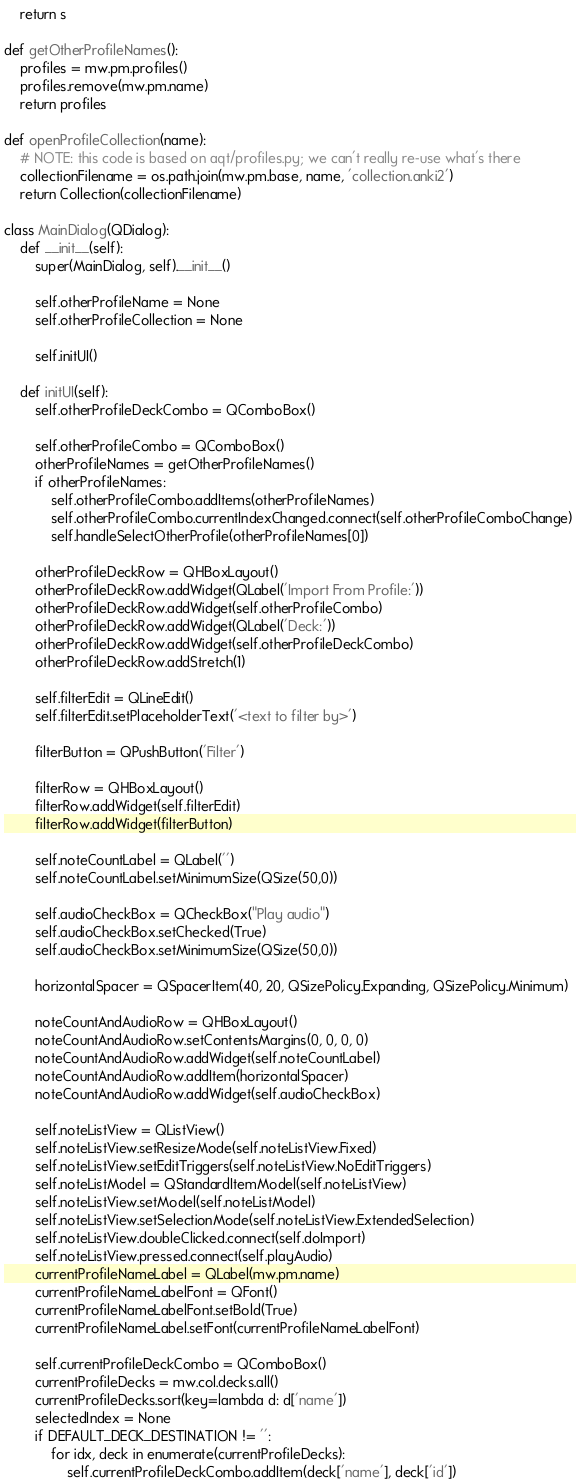Convert code to text. <code><loc_0><loc_0><loc_500><loc_500><_Python_>    return s

def getOtherProfileNames():
    profiles = mw.pm.profiles()
    profiles.remove(mw.pm.name)
    return profiles

def openProfileCollection(name):
    # NOTE: this code is based on aqt/profiles.py; we can't really re-use what's there
    collectionFilename = os.path.join(mw.pm.base, name, 'collection.anki2')
    return Collection(collectionFilename)

class MainDialog(QDialog):
    def __init__(self):
        super(MainDialog, self).__init__()

        self.otherProfileName = None
        self.otherProfileCollection = None

        self.initUI()

    def initUI(self):
        self.otherProfileDeckCombo = QComboBox()

        self.otherProfileCombo = QComboBox()
        otherProfileNames = getOtherProfileNames()
        if otherProfileNames:
            self.otherProfileCombo.addItems(otherProfileNames)
            self.otherProfileCombo.currentIndexChanged.connect(self.otherProfileComboChange)
            self.handleSelectOtherProfile(otherProfileNames[0])

        otherProfileDeckRow = QHBoxLayout()
        otherProfileDeckRow.addWidget(QLabel('Import From Profile:'))
        otherProfileDeckRow.addWidget(self.otherProfileCombo)
        otherProfileDeckRow.addWidget(QLabel('Deck:'))
        otherProfileDeckRow.addWidget(self.otherProfileDeckCombo)
        otherProfileDeckRow.addStretch(1)

        self.filterEdit = QLineEdit()
        self.filterEdit.setPlaceholderText('<text to filter by>')

        filterButton = QPushButton('Filter')

        filterRow = QHBoxLayout()
        filterRow.addWidget(self.filterEdit)
        filterRow.addWidget(filterButton)

        self.noteCountLabel = QLabel('')
        self.noteCountLabel.setMinimumSize(QSize(50,0))

        self.audioCheckBox = QCheckBox("Play audio")
        self.audioCheckBox.setChecked(True)
        self.audioCheckBox.setMinimumSize(QSize(50,0))

        horizontalSpacer = QSpacerItem(40, 20, QSizePolicy.Expanding, QSizePolicy.Minimum)

        noteCountAndAudioRow = QHBoxLayout()
        noteCountAndAudioRow.setContentsMargins(0, 0, 0, 0)
        noteCountAndAudioRow.addWidget(self.noteCountLabel)
        noteCountAndAudioRow.addItem(horizontalSpacer)
        noteCountAndAudioRow.addWidget(self.audioCheckBox)

        self.noteListView = QListView()
        self.noteListView.setResizeMode(self.noteListView.Fixed)
        self.noteListView.setEditTriggers(self.noteListView.NoEditTriggers)
        self.noteListModel = QStandardItemModel(self.noteListView)
        self.noteListView.setModel(self.noteListModel)
        self.noteListView.setSelectionMode(self.noteListView.ExtendedSelection)
        self.noteListView.doubleClicked.connect(self.doImport)
        self.noteListView.pressed.connect(self.playAudio)
        currentProfileNameLabel = QLabel(mw.pm.name)
        currentProfileNameLabelFont = QFont()
        currentProfileNameLabelFont.setBold(True)
        currentProfileNameLabel.setFont(currentProfileNameLabelFont)

        self.currentProfileDeckCombo = QComboBox()
        currentProfileDecks = mw.col.decks.all()
        currentProfileDecks.sort(key=lambda d: d['name'])
        selectedIndex = None
        if DEFAULT_DECK_DESTINATION != '':
            for idx, deck in enumerate(currentProfileDecks):
                self.currentProfileDeckCombo.addItem(deck['name'], deck['id'])</code> 